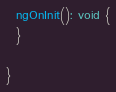Convert code to text. <code><loc_0><loc_0><loc_500><loc_500><_TypeScript_>
  ngOnInit(): void {
  }

}
</code> 